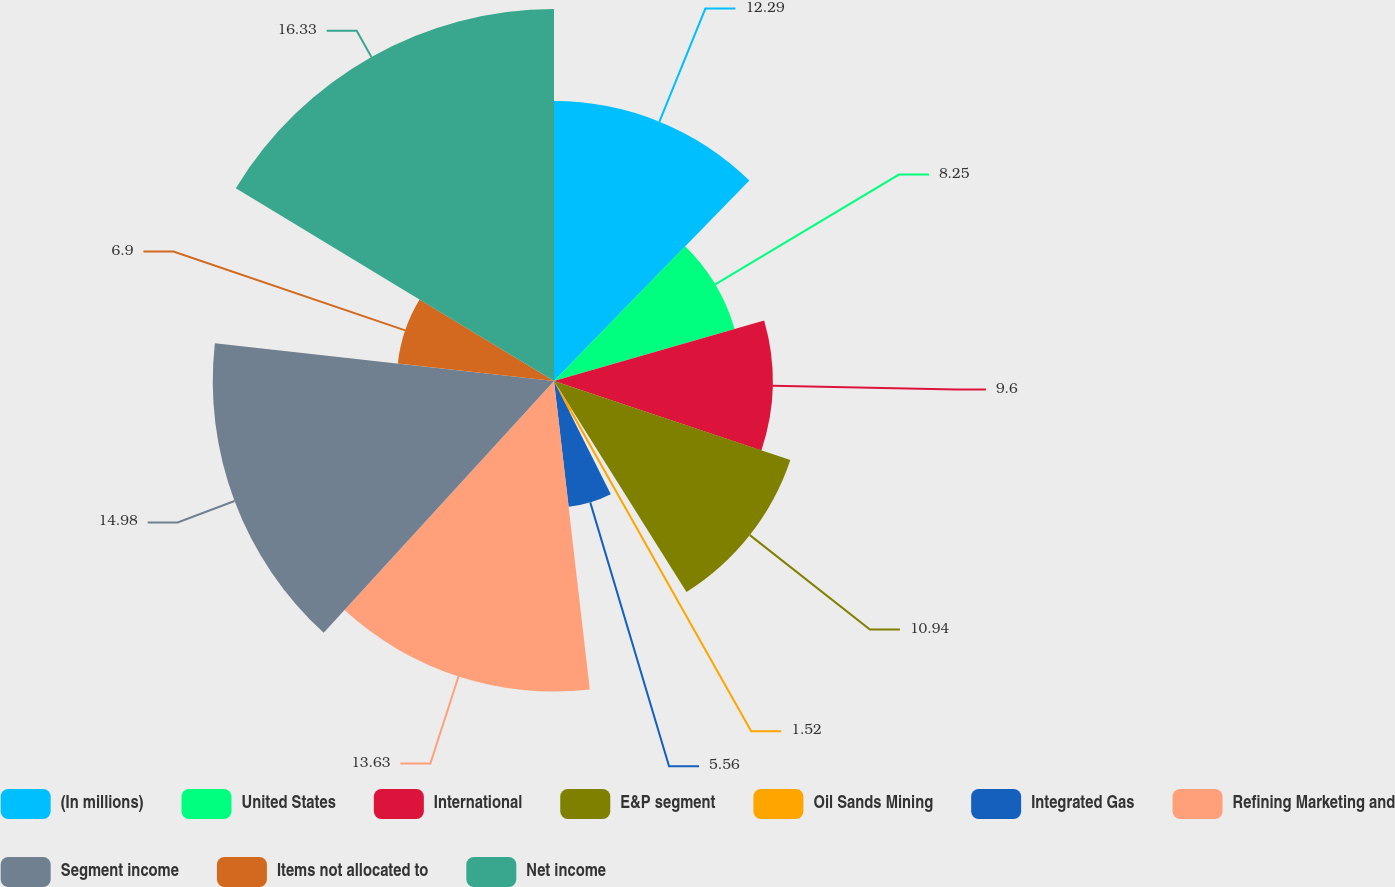Convert chart. <chart><loc_0><loc_0><loc_500><loc_500><pie_chart><fcel>(In millions)<fcel>United States<fcel>International<fcel>E&P segment<fcel>Oil Sands Mining<fcel>Integrated Gas<fcel>Refining Marketing and<fcel>Segment income<fcel>Items not allocated to<fcel>Net income<nl><fcel>12.29%<fcel>8.25%<fcel>9.6%<fcel>10.94%<fcel>1.52%<fcel>5.56%<fcel>13.63%<fcel>14.98%<fcel>6.9%<fcel>16.33%<nl></chart> 